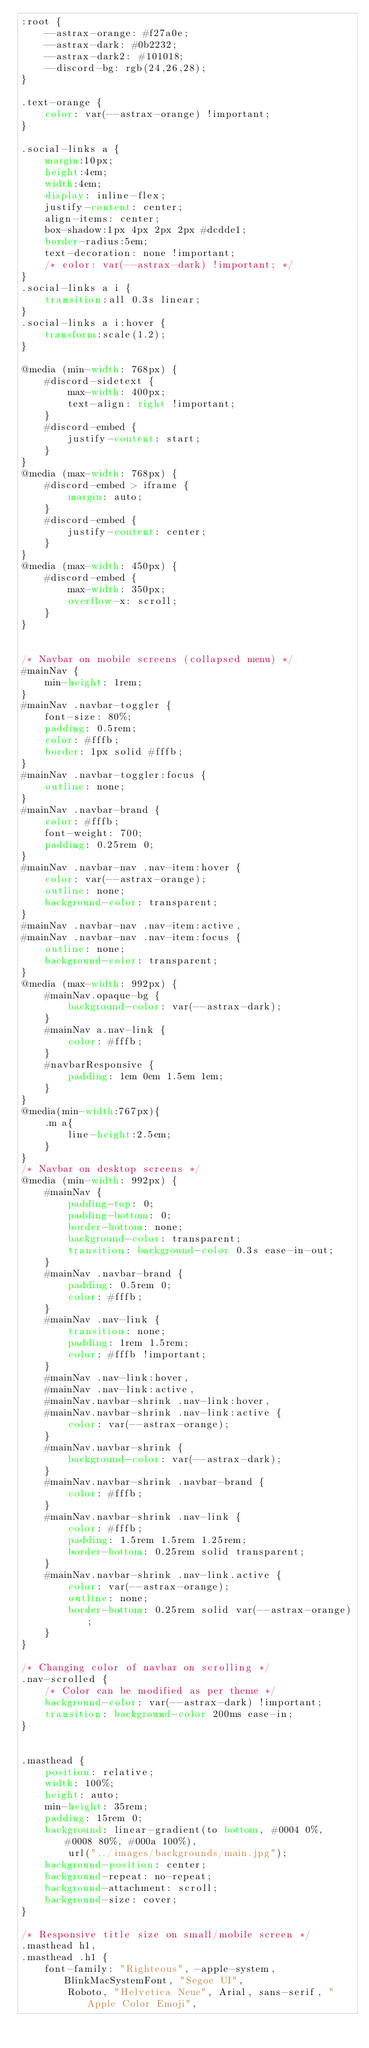Convert code to text. <code><loc_0><loc_0><loc_500><loc_500><_CSS_>:root {
    --astrax-orange: #f27a0e;
    --astrax-dark: #0b2232;
    --astrax-dark2: #101018;
    --discord-bg: rgb(24,26,28);
}

.text-orange {
    color: var(--astrax-orange) !important;
}

.social-links a {
    margin:10px;
    height:4em;
    width:4em;
    display: inline-flex;
    justify-content: center;
    align-items: center;
    box-shadow:1px 4px 2px 2px #dcdde1;
    border-radius:5em;
    text-decoration: none !important;
    /* color: var(--astrax-dark) !important; */
}
.social-links a i {
    transition:all 0.3s linear;
}
.social-links a i:hover {
    transform:scale(1.2);
}

@media (min-width: 768px) {
    #discord-sidetext {
        max-width: 400px;
        text-align: right !important;
    }
    #discord-embed {
        justify-content: start;
    }
}
@media (max-width: 768px) {
    #discord-embed > iframe {
        margin: auto;
    }
    #discord-embed {
        justify-content: center;
    }
}
@media (max-width: 450px) {
    #discord-embed {
        max-width: 350px;
        overflow-x: scroll;
    }
}


/* Navbar on mobile screens (collapsed menu) */
#mainNav {
    min-height: 1rem;
}
#mainNav .navbar-toggler {
    font-size: 80%;
    padding: 0.5rem;
    color: #fffb;
    border: 1px solid #fffb;
}
#mainNav .navbar-toggler:focus {
    outline: none;
}
#mainNav .navbar-brand {
    color: #fffb;
    font-weight: 700;
    padding: 0.25rem 0;
}
#mainNav .navbar-nav .nav-item:hover {
    color: var(--astrax-orange);
    outline: none;
    background-color: transparent;
}
#mainNav .navbar-nav .nav-item:active,
#mainNav .navbar-nav .nav-item:focus {
    outline: none;
    background-color: transparent;
}
@media (max-width: 992px) {
    #mainNav.opaque-bg {
        background-color: var(--astrax-dark);
    }
    #mainNav a.nav-link {
        color: #fffb;
    }
    #navbarResponsive {
        padding: 1em 0em 1.5em 1em;
    }
}
@media(min-width:767px){
    .m a{
        line-height:2.5em;
    }
}
/* Navbar on desktop screens */
@media (min-width: 992px) {
    #mainNav {
        padding-top: 0;
        padding-bottom: 0;
        border-bottom: none;
        background-color: transparent;
        transition: background-color 0.3s ease-in-out;
    }
    #mainNav .navbar-brand {
        padding: 0.5rem 0;
        color: #fffb;
    }
    #mainNav .nav-link {
        transition: none;
        padding: 1rem 1.5rem;
        color: #fffb !important;
    }
    #mainNav .nav-link:hover,
    #mainNav .nav-link:active,
    #mainNav.navbar-shrink .nav-link:hover,
    #mainNav.navbar-shrink .nav-link:active {
        color: var(--astrax-orange);
    }
    #mainNav.navbar-shrink {
        background-color: var(--astrax-dark);
    }
    #mainNav.navbar-shrink .navbar-brand {
        color: #fffb;
    }
    #mainNav.navbar-shrink .nav-link {
        color: #fffb;
        padding: 1.5rem 1.5rem 1.25rem;
        border-bottom: 0.25rem solid transparent;
    }
    #mainNav.navbar-shrink .nav-link.active {
        color: var(--astrax-orange);
        outline: none;
        border-bottom: 0.25rem solid var(--astrax-orange);
    }
}

/* Changing color of navbar on scrolling */
.nav-scrolled {
    /* Color can be modified as per theme */
    background-color: var(--astrax-dark) !important;
    transition: background-color 200ms ease-in;
}


.masthead {
    position: relative;
    width: 100%;
    height: auto;
    min-height: 35rem;
    padding: 15rem 0;
    background: linear-gradient(to bottom, #0004 0%, #0008 80%, #000a 100%),
        url("../images/backgrounds/main.jpg");
    background-position: center;
    background-repeat: no-repeat;
    background-attachment: scroll;
    background-size: cover;
}

/* Responsive title size on small/mobile screen */
.masthead h1,
.masthead .h1 {
    font-family: "Righteous", -apple-system, BlinkMacSystemFont, "Segoe UI",
        Roboto, "Helvetica Neue", Arial, sans-serif, "Apple Color Emoji",</code> 